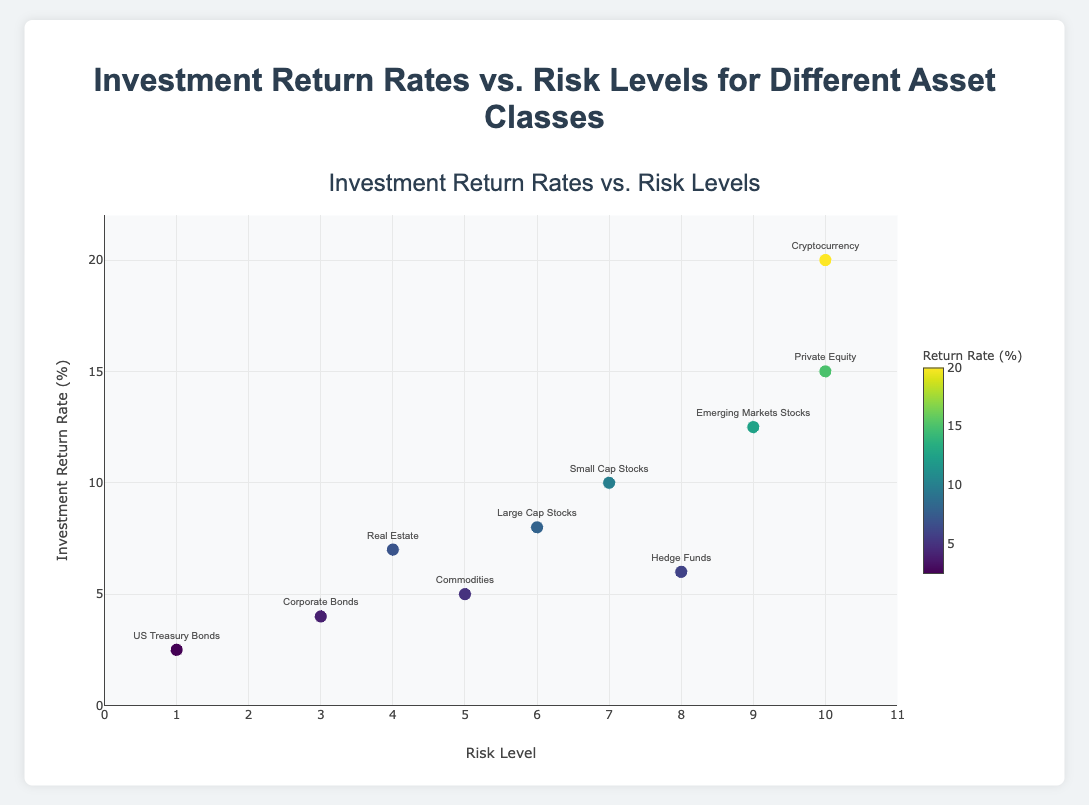What's the title of the figure? The title of the figure is displayed at the top and reads "Investment Return Rates vs. Risk Levels for Different Asset Classes".
Answer: Investment Return Rates vs. Risk Levels for Different Asset Classes How many asset classes are represented in the figure? Each dot labeled with an asset class represents a unique data point. There are 10 dots on the plot, each corresponding to one asset class.
Answer: 10 Which asset class has the highest investment return rate? The data point at the highest position on the Y-axis represents the highest return rate. The dot at the top corresponds to Cryptocurrency, which has a return rate of 20%.
Answer: Cryptocurrency What is the Risk Level of Hedge Funds? Locate the dot labeled "Hedge Funds" and refer to its position on the X-axis representing risk level. The dot is at a risk level of 8.
Answer: 8 Which asset class has the lowest risk level? The data point at the furthest left on the X-axis represents the lowest risk level. The dot on the far left corresponds to US Treasury Bonds with a risk level of 1.
Answer: US Treasury Bonds What is the difference in investment return rate between Large Cap Stocks and Small Cap Stocks? Find the dots labeled "Large Cap Stocks" and "Small Cap Stocks" on the Y-axis. Large Cap Stocks have a return rate of 8.0% and Small Cap Stocks have a return rate of 10.0%. The difference is 10.0 - 8.0 = 2.0%.
Answer: 2.0% Which asset class has both a high risk level and high return rate? The data points located at the upper right quadrant of the plot have both high risk and high return. Cryptocurrency and Private Equity are in the upper right with high risk levels (10) and high return rates (20% and 15%, respectively).
Answer: Cryptocurrency, Private Equity How many asset classes have a risk level greater than or equal to 7? Identify the dots on the right side of the plot with risk levels 7 and above. The asset classes are Small Cap Stocks, Emerging Markets Stocks, Hedge Funds, Private Equity, and Cryptocurrency. There are 5 in total.
Answer: 5 What is the average investment return rate of all the asset classes? Sum all the investment return rates and divide by the number of asset classes: (2.5 + 4.0 + 7.0 + 8.0 + 10.0 + 12.5 + 6.0 + 15.0 + 5.0 + 20.0) / 10 = 9.1%.
Answer: 9.1% Among the asset classes with a return rate over 10%, which has the lowest risk level? Identify the dots with a return rate greater than 10%. These asset classes are Emerging Markets Stocks (9 risk), Private Equity (10 risk), and Cryptocurrency (10 risk). Emerging Markets Stocks has the lowest risk level of 9.
Answer: Emerging Markets Stocks 